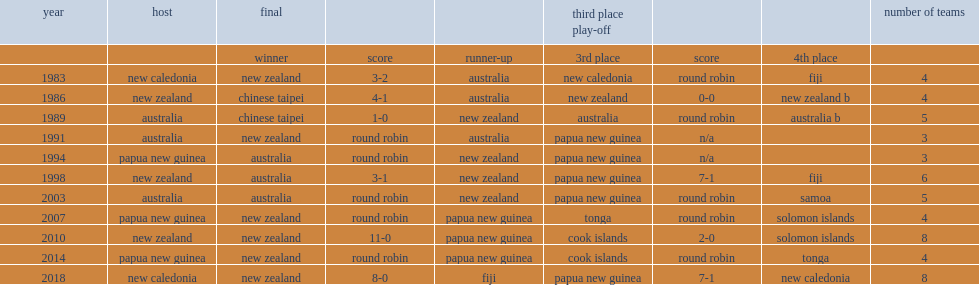What is the final result for the second edition of the ofc women's nations cup in 1986 hosted by new zealand? 4-1. 